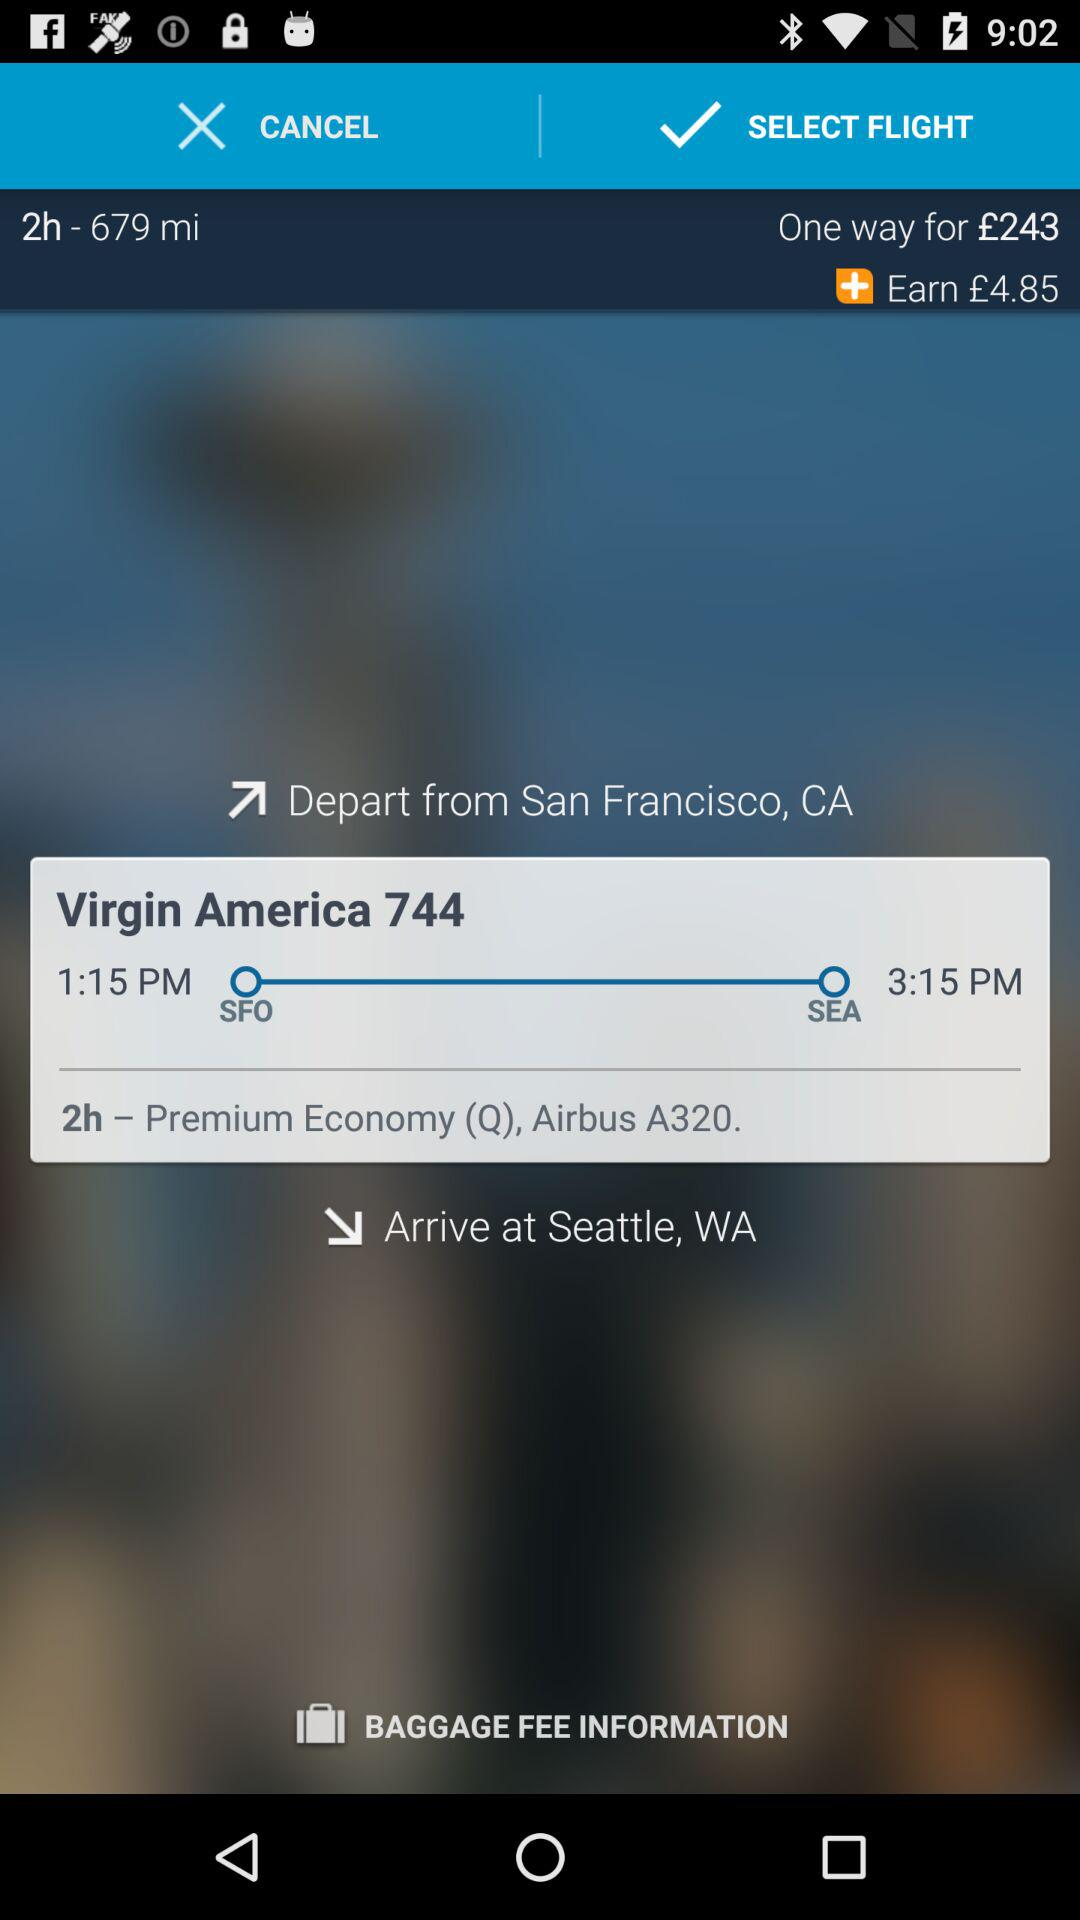What is the flying distance between San Francisco and Seattle? The flight between San Francisco (SFO) and Seattle (SEA) covers a flying distance of roughly 679 miles. Could you provide information on the luggage policy for this flight? I'm unable to provide specifics on the luggage policy without additional data. Generally, Virgin America permits one carry-on bag and one personal item for free in the cabin. However, you should verify the most current baggage policy directly with the airline, as it may differ based on fare type or loyalty membership status. You can also click on the 'BAGGAGE FEE INFORMATION' link, if accessible, to obtain precise details. 